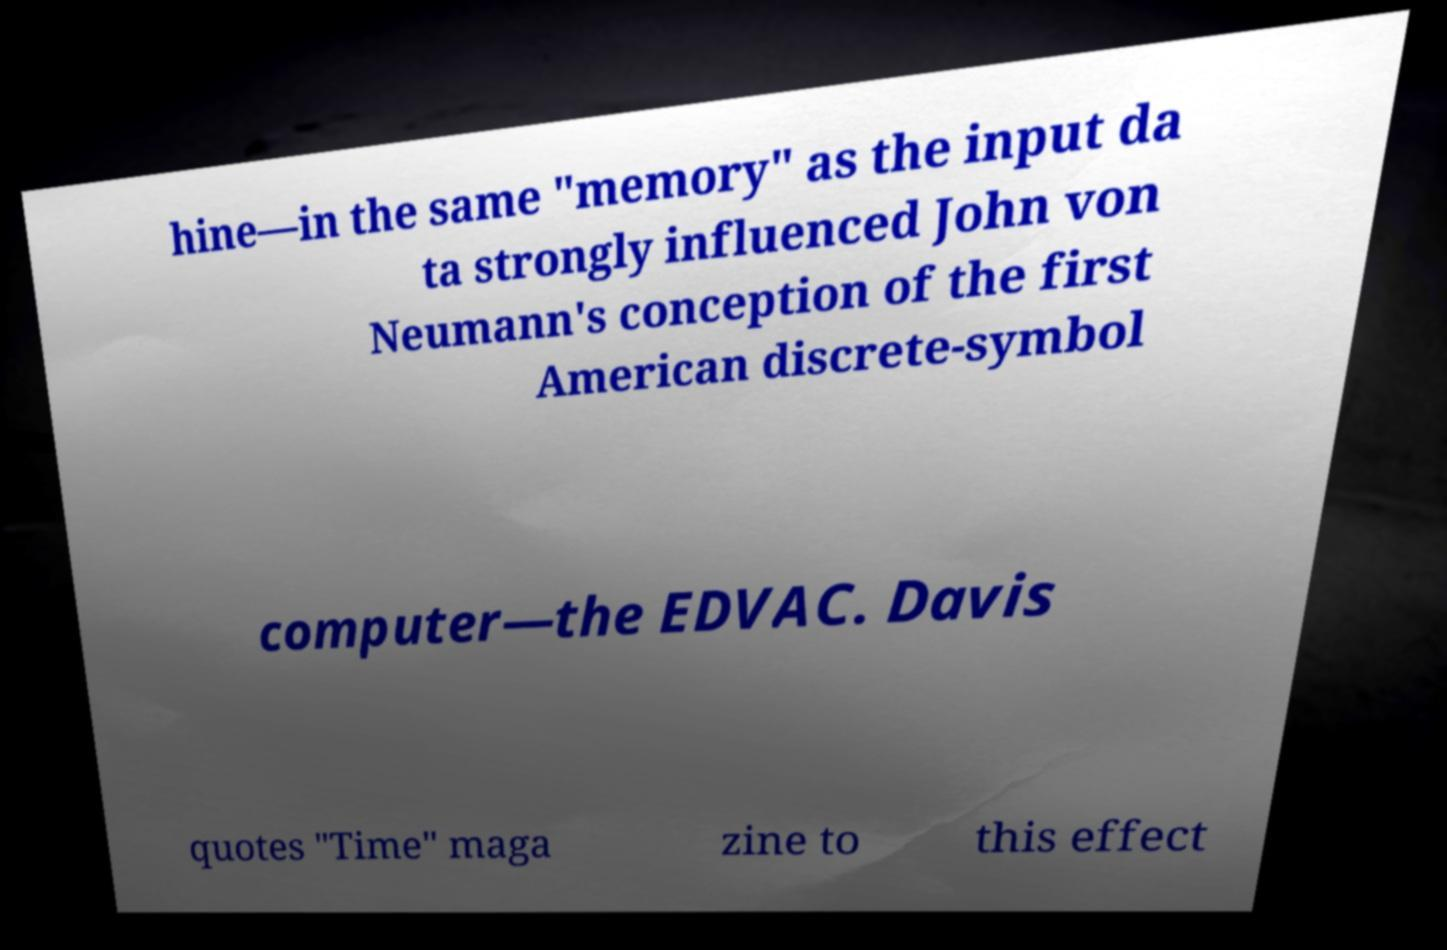There's text embedded in this image that I need extracted. Can you transcribe it verbatim? hine—in the same "memory" as the input da ta strongly influenced John von Neumann's conception of the first American discrete-symbol computer—the EDVAC. Davis quotes "Time" maga zine to this effect 